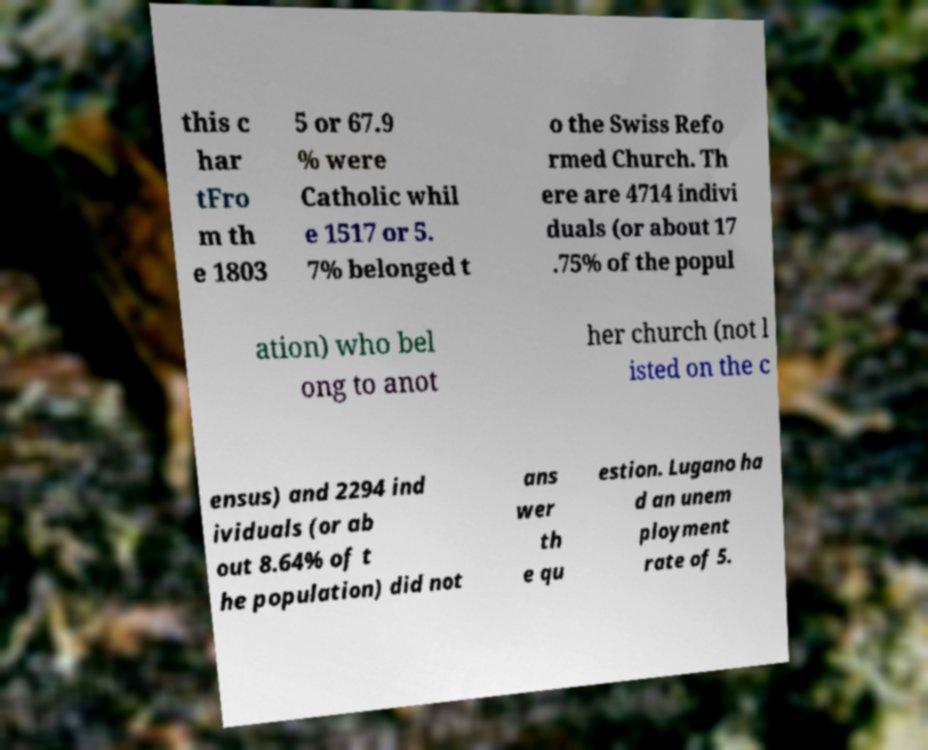Could you extract and type out the text from this image? this c har tFro m th e 1803 5 or 67.9 % were Catholic whil e 1517 or 5. 7% belonged t o the Swiss Refo rmed Church. Th ere are 4714 indivi duals (or about 17 .75% of the popul ation) who bel ong to anot her church (not l isted on the c ensus) and 2294 ind ividuals (or ab out 8.64% of t he population) did not ans wer th e qu estion. Lugano ha d an unem ployment rate of 5. 